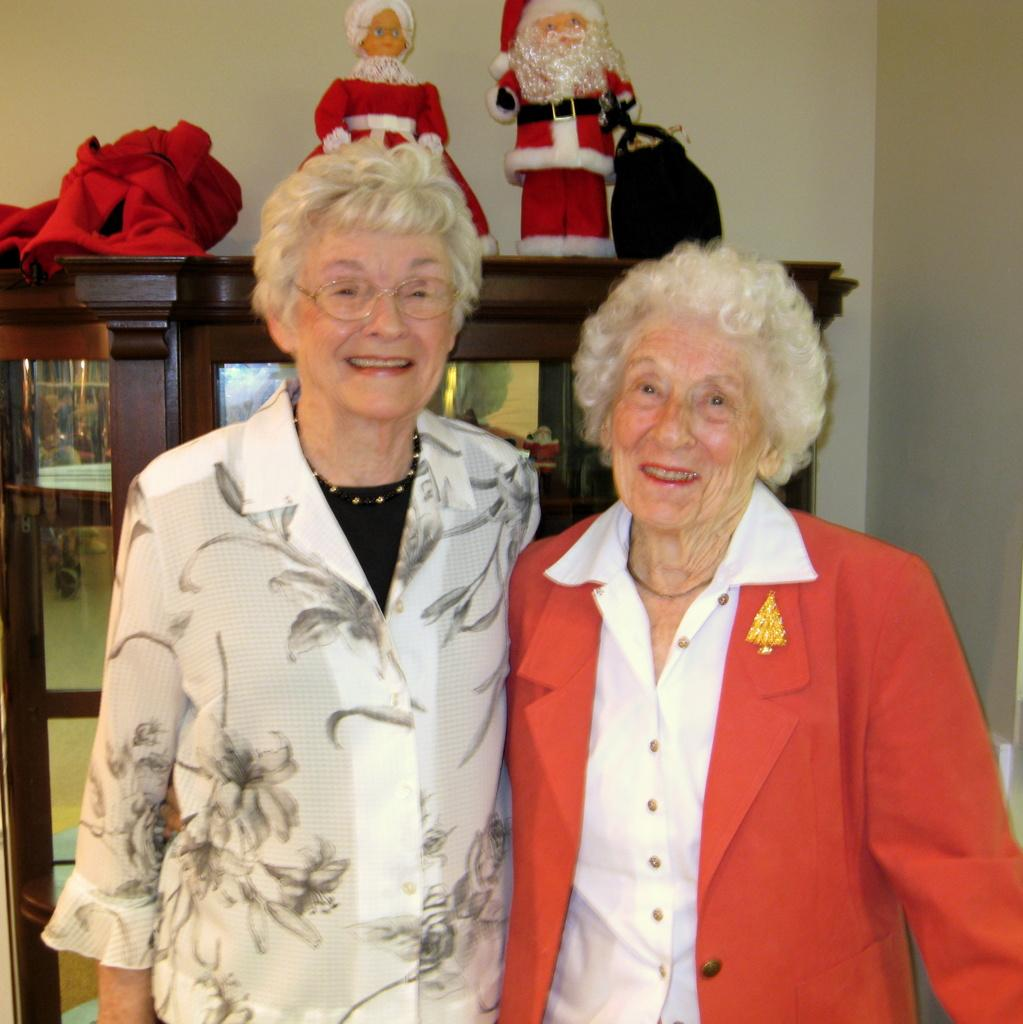How many people are in the image? There are two old people in the image. What are the old people doing in the image? The old people are standing in the image. What are the old people holding in the image? The old people are holding something in the image. What can be seen on the wooden shelf in the image? There is a wooden shelf in the image. What type of items are present in the image? There are toys in the image. What type of blood is visible on the toys in the image? There is no blood visible on the toys in the image. What division of labor can be observed between the old people in the image? There is no division of labor mentioned or visible in the image. 